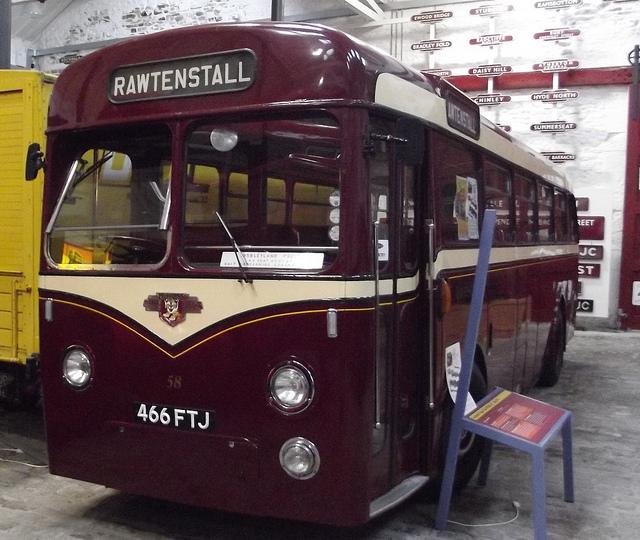What does the information on the blue legged placard describe? Please explain your reasoning. bus. The information is on rawtenstall bus. 